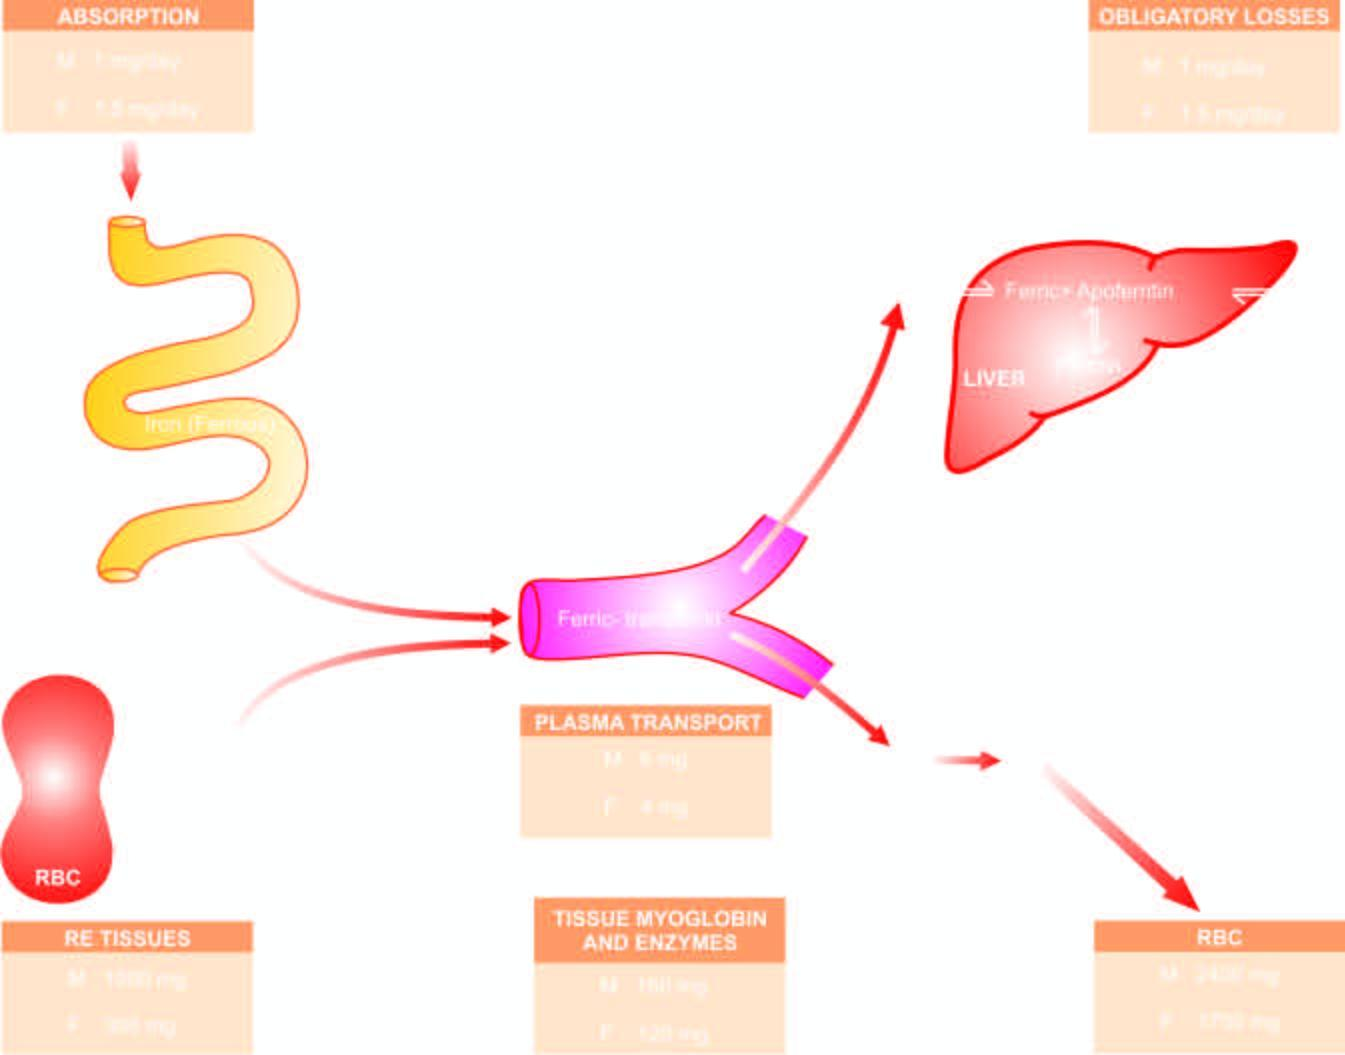does iron on absorption from upper small intestine circulate in plasma bound to transferrin and is transported to the bone marrow for utilisation in haemoglobin synthesis?
Answer the question using a single word or phrase. Yes 